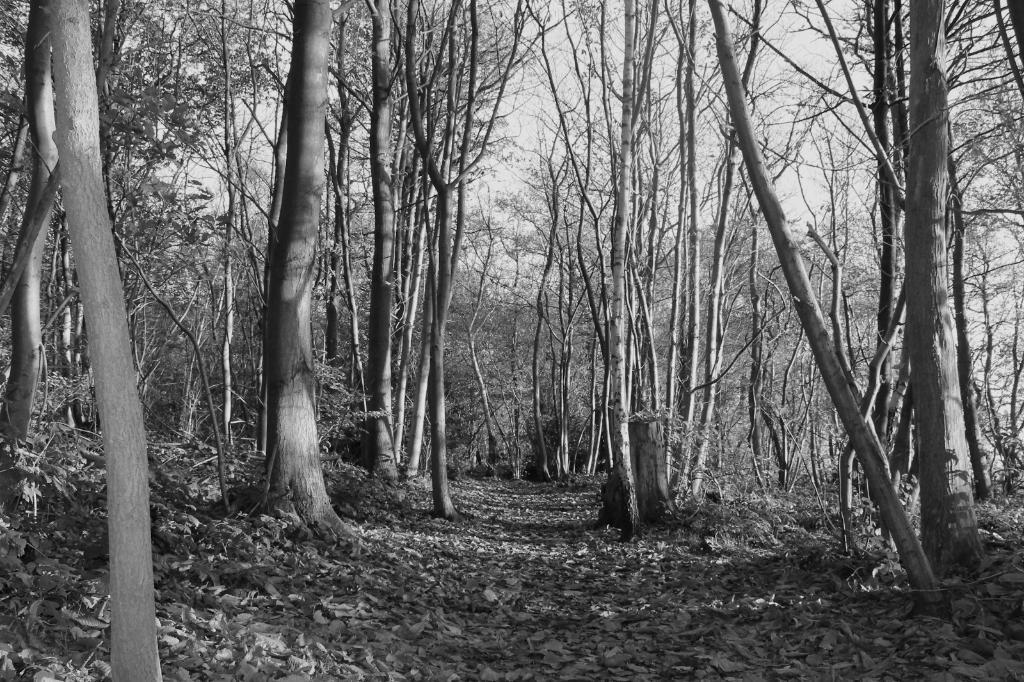What is the color scheme of the image? The image is black and white. What type of natural elements can be seen in the image? There is a group of trees in the image. What part of the trees is visible? The bark of the trees is visible. What is present on the ground in the image? There are dried leaves on the ground. What is visible in the background of the image? The sky is visible in the image. What type of protest is taking place in the image? There is no protest present in the image; it features a group of trees with visible bark and dried leaves on the ground. Can you point out the map in the image? There is no map present in the image; it is a black and white photograph of a group of trees. 